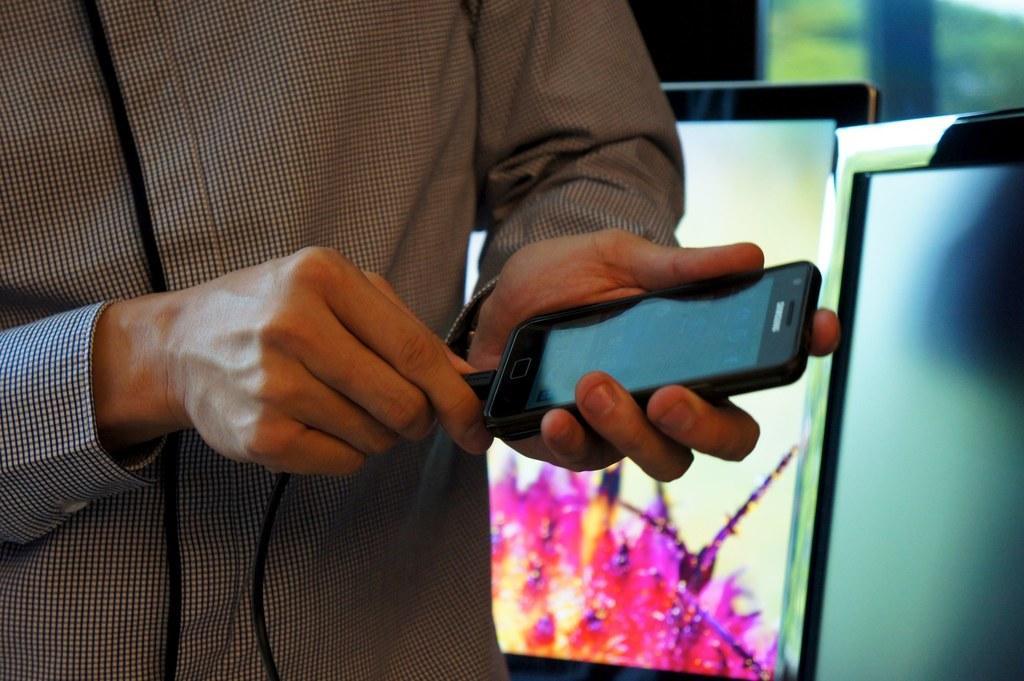In one or two sentences, can you explain what this image depicts? In this picture a man with checked shirt is holding a charger and a mobile phone with both of his hands. In the background there are two monitors and also a glass window. 